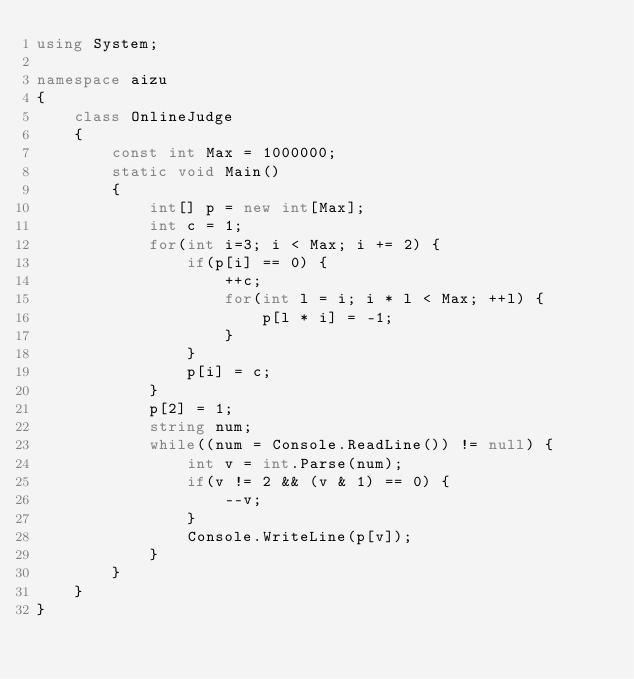<code> <loc_0><loc_0><loc_500><loc_500><_C#_>using System;
 
namespace aizu
{
    class OnlineJudge
    {
        const int Max = 1000000;
        static void Main()
        {
            int[] p = new int[Max];
            int c = 1;
            for(int i=3; i < Max; i += 2) {
                if(p[i] == 0) {
                    ++c;
                    for(int l = i; i * l < Max; ++l) {
                        p[l * i] = -1;
                    }
                }
                p[i] = c;
            }
            p[2] = 1;
            string num;
            while((num = Console.ReadLine()) != null) {
                int v = int.Parse(num);
                if(v != 2 && (v & 1) == 0) {
                    --v;
                }
                Console.WriteLine(p[v]);
            }
        }
    }
}</code> 